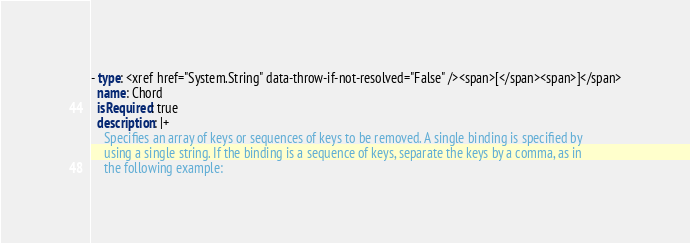Convert code to text. <code><loc_0><loc_0><loc_500><loc_500><_YAML_>- type: <xref href="System.String" data-throw-if-not-resolved="False" /><span>[</span><span>]</span>
  name: Chord
  isRequired: true
  description: |+
    Specifies an array of keys or sequences of keys to be removed. A single binding is specified by
    using a single string. If the binding is a sequence of keys, separate the keys by a comma, as in
    the following example:
</code> 